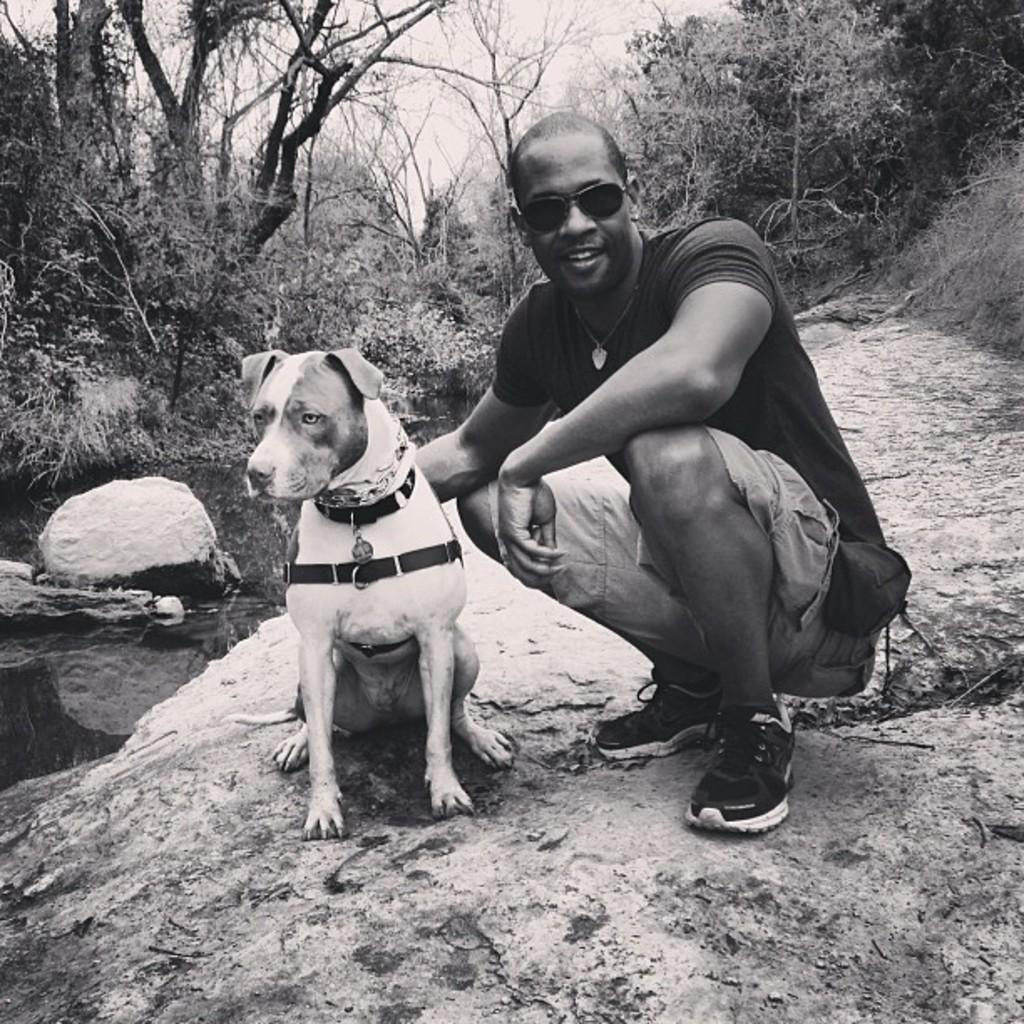What is the color scheme of the image? The image is black and white. What can be seen on the rock in the image? There is a dog and a man on the rock in the image. What is visible in the background of the image? Trees and the sky are visible in the background of the image. What type of sweater is the dog wearing in the image? There is no sweater present in the image, as the dog is not wearing any clothing. 